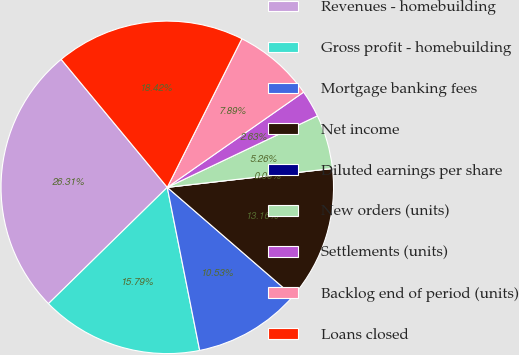Convert chart. <chart><loc_0><loc_0><loc_500><loc_500><pie_chart><fcel>Revenues - homebuilding<fcel>Gross profit - homebuilding<fcel>Mortgage banking fees<fcel>Net income<fcel>Diluted earnings per share<fcel>New orders (units)<fcel>Settlements (units)<fcel>Backlog end of period (units)<fcel>Loans closed<nl><fcel>26.31%<fcel>15.79%<fcel>10.53%<fcel>13.16%<fcel>0.0%<fcel>5.26%<fcel>2.63%<fcel>7.89%<fcel>18.42%<nl></chart> 